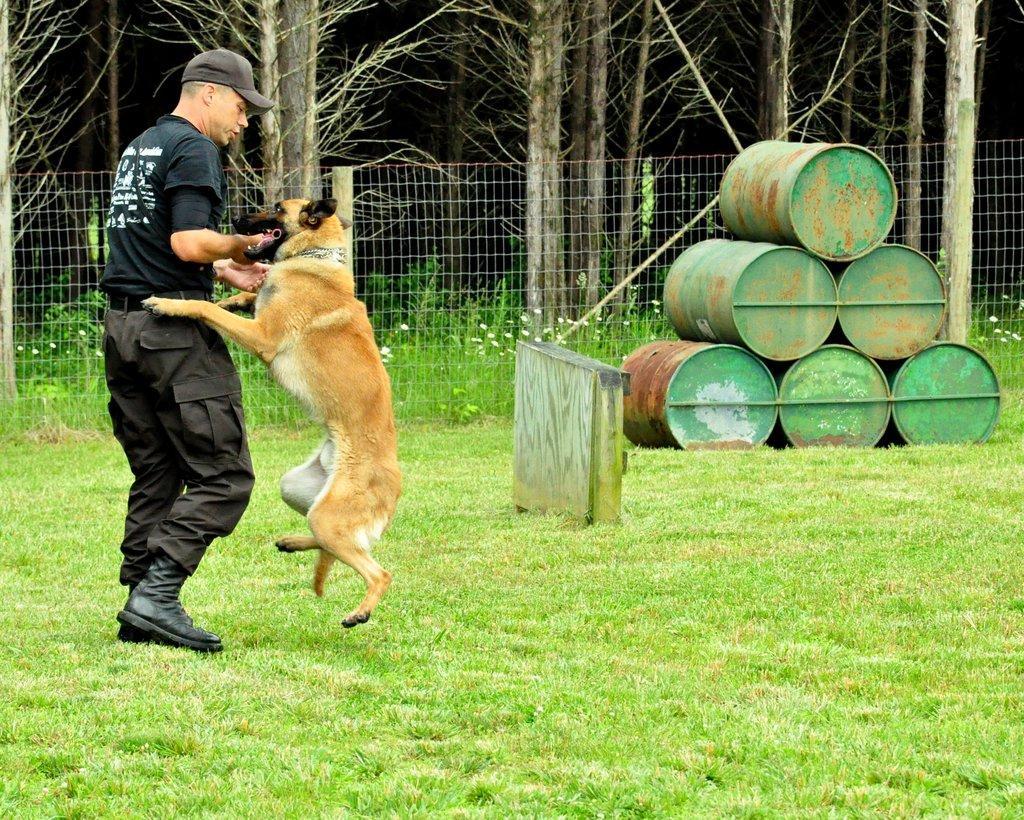Can you describe this image briefly? In this image there is a men and a dog standing on a ground, in the background there are drums, fencing and trees. 